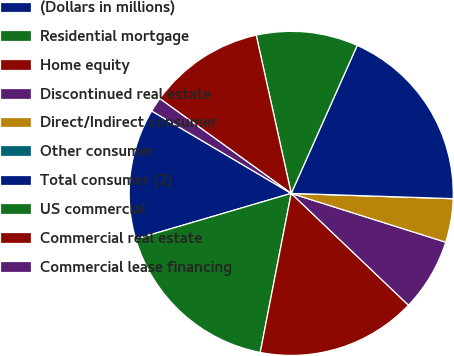Convert chart. <chart><loc_0><loc_0><loc_500><loc_500><pie_chart><fcel>(Dollars in millions)<fcel>Residential mortgage<fcel>Home equity<fcel>Discontinued real estate<fcel>Direct/Indirect consumer<fcel>Other consumer<fcel>Total consumer (2)<fcel>US commercial<fcel>Commercial real estate<fcel>Commercial lease financing<nl><fcel>13.04%<fcel>17.39%<fcel>15.94%<fcel>7.25%<fcel>4.35%<fcel>0.0%<fcel>18.84%<fcel>10.14%<fcel>11.59%<fcel>1.45%<nl></chart> 